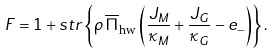<formula> <loc_0><loc_0><loc_500><loc_500>F = { 1 } + s t r \left \{ \rho \, \overline { \Pi } _ { \text {hw} } \left ( \frac { J _ { M } } { \kappa _ { M } } + \frac { J _ { G } } { \kappa _ { G } } - e _ { - } \right ) \right \} .</formula> 